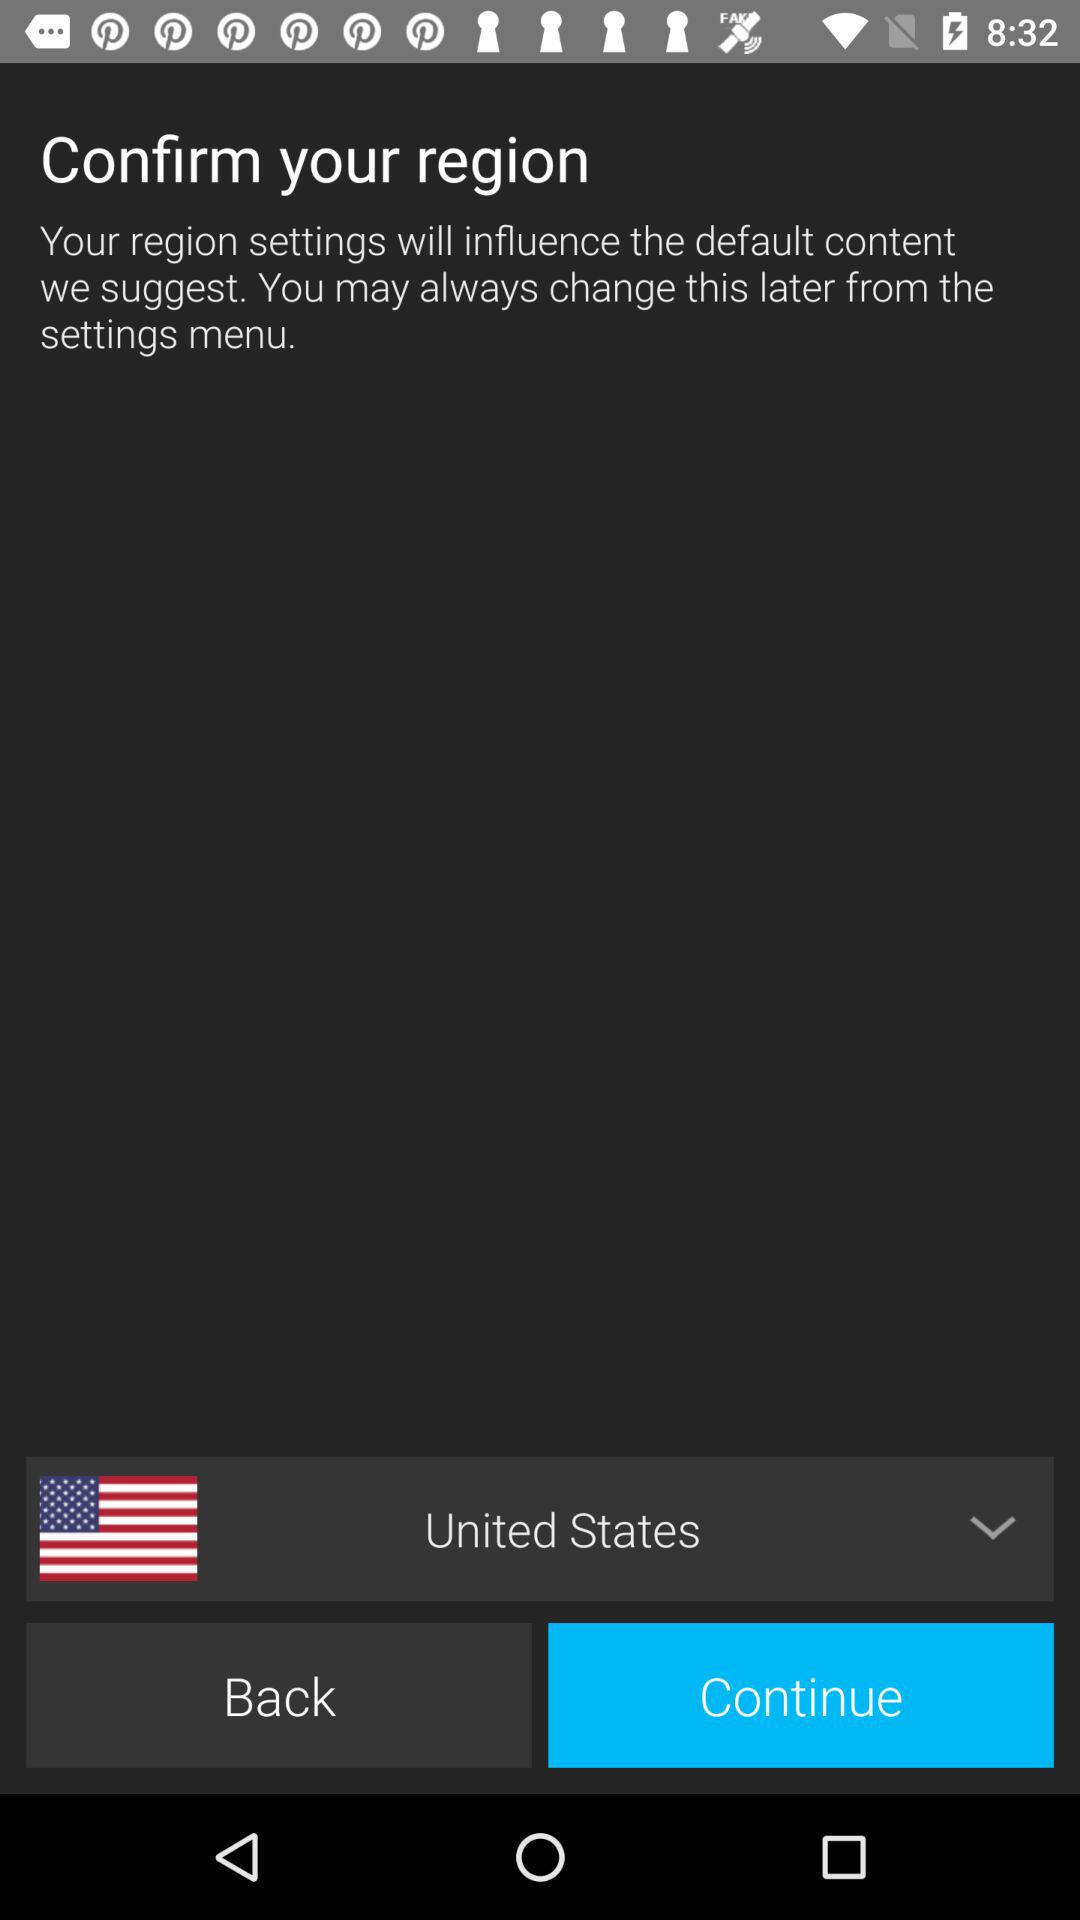What is the region name? The region is the United States. 